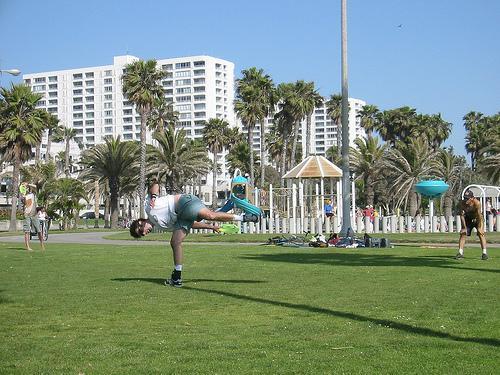How many people are holding a green frisbee?
Give a very brief answer. 2. 